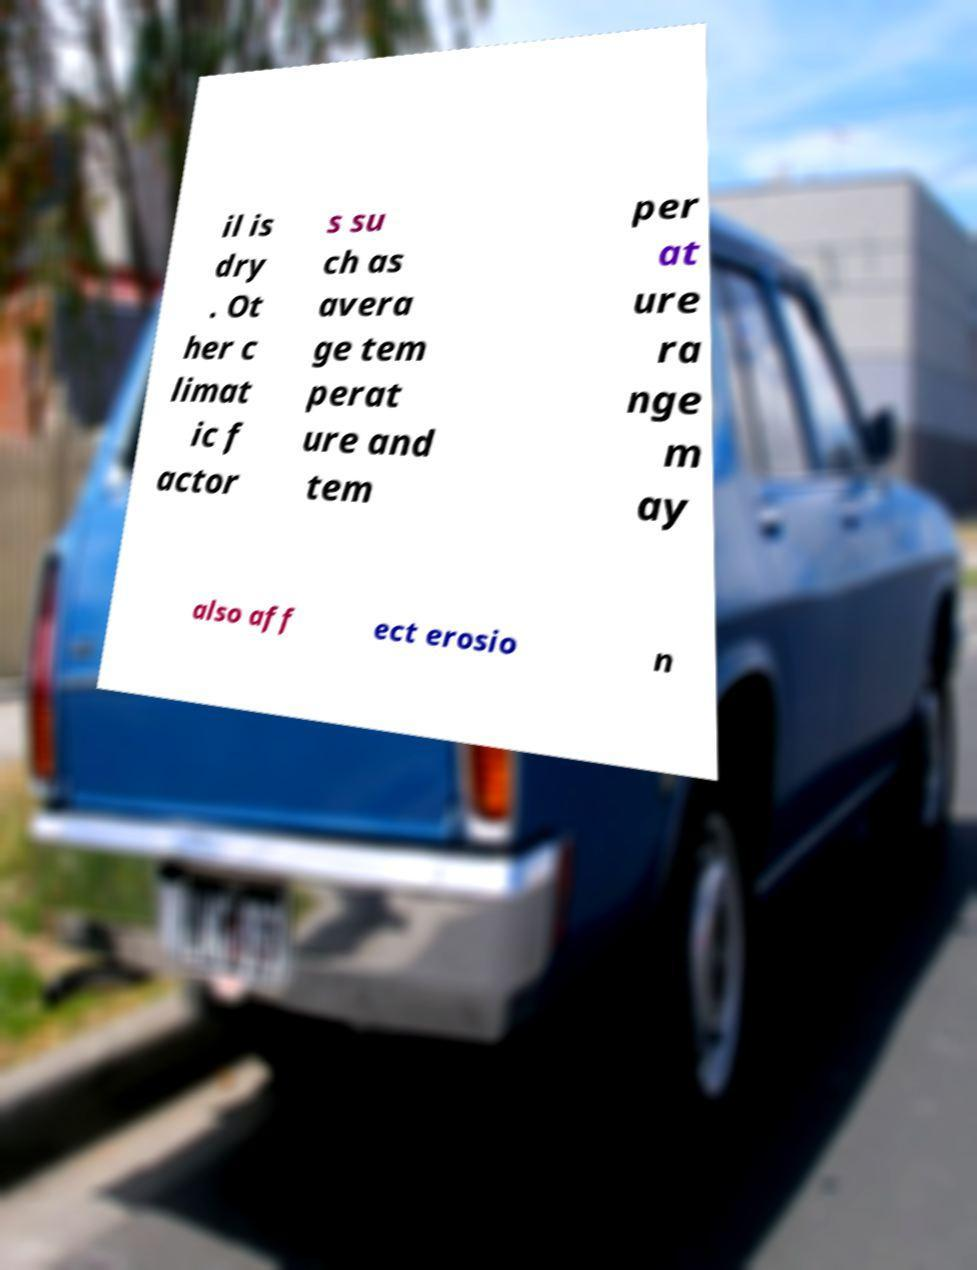What messages or text are displayed in this image? I need them in a readable, typed format. il is dry . Ot her c limat ic f actor s su ch as avera ge tem perat ure and tem per at ure ra nge m ay also aff ect erosio n 